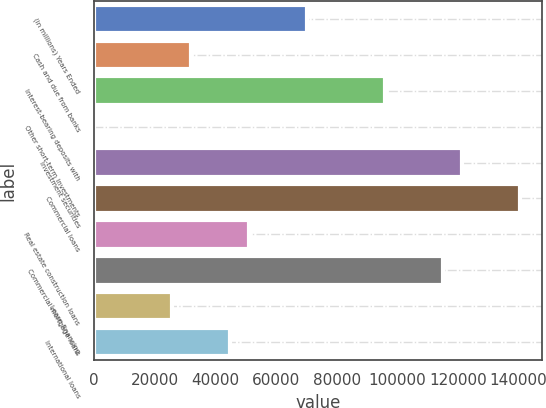Convert chart. <chart><loc_0><loc_0><loc_500><loc_500><bar_chart><fcel>(in millions) Years Ended<fcel>Cash and due from banks<fcel>Interest-bearing deposits with<fcel>Other short-term investments<fcel>Investment securities<fcel>Commercial loans<fcel>Real estate construction loans<fcel>Commercial mortgage loans<fcel>Lease financing<fcel>International loans<nl><fcel>70315.1<fcel>32022.5<fcel>95843.5<fcel>112<fcel>121372<fcel>140518<fcel>51168.8<fcel>114990<fcel>25640.4<fcel>44786.7<nl></chart> 